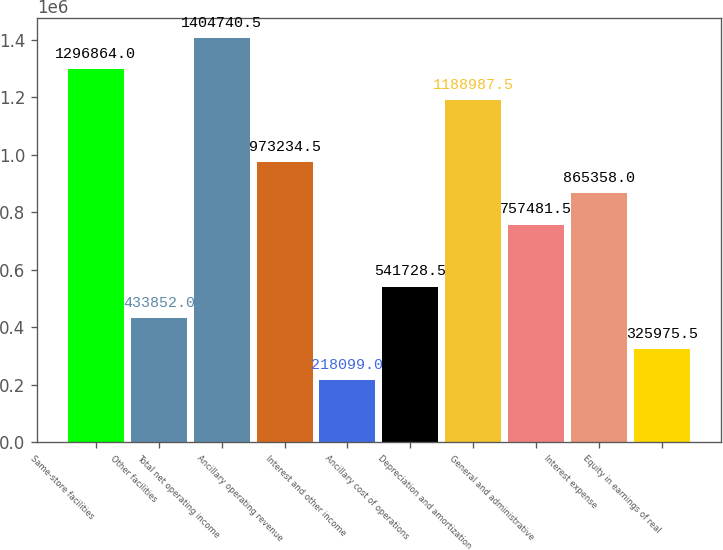Convert chart. <chart><loc_0><loc_0><loc_500><loc_500><bar_chart><fcel>Same-store facilities<fcel>Other facilities<fcel>Total net operating income<fcel>Ancillary operating revenue<fcel>Interest and other income<fcel>Ancillary cost of operations<fcel>Depreciation and amortization<fcel>General and administrative<fcel>Interest expense<fcel>Equity in earnings of real<nl><fcel>1.29686e+06<fcel>433852<fcel>1.40474e+06<fcel>973234<fcel>218099<fcel>541728<fcel>1.18899e+06<fcel>757482<fcel>865358<fcel>325976<nl></chart> 